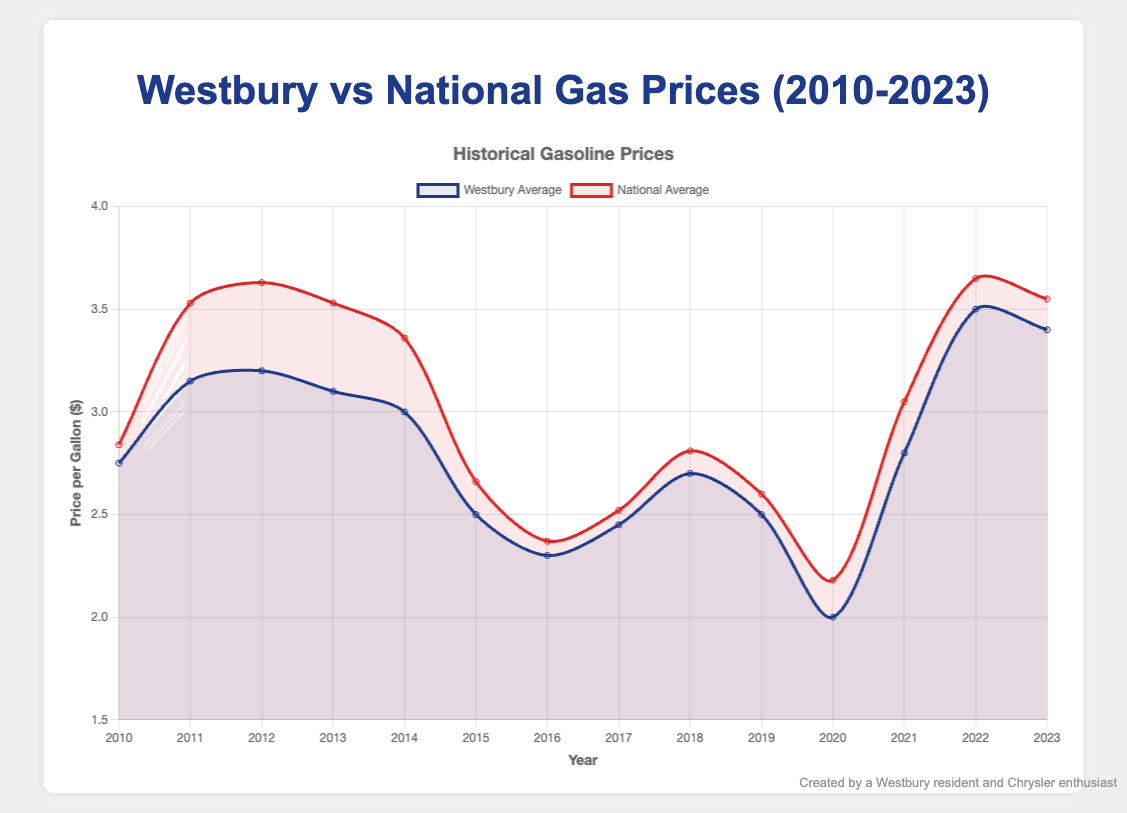What was the highest average gas price in Westbury, and in which year did it occur? To find this, look for the highest point in the blue line representing Westbury. The peak is $3.50 in 2022.
Answer: $3.50 in 2022 In which year was the difference between Westbury and the national average gasoline prices the largest? Calculate the absolute difference for each year. The largest difference is in 2012 with Westbury at $3.20 and the national average at $3.63, resulting in a difference of $0.43.
Answer: 2012 Compare the trends in gasoline prices for Westbury and the national average from 2010 to 2023. Did they generally follow the same pattern? Both lines should be compared for overall upward and downward trends. Both lines show similar oscillations over the years, albeit at slightly different values.
Answer: Yes Was there any year in which Westbury's average gas price was higher than the national average? Look for points where the blue line is above the red line. There is no such year; Westbury's prices were always lower or equal.
Answer: No What was the price difference between the Westbury and national averages in 2023? Subtract Westbury's price from the national average for 2023. $3.55 (national average) - $3.40 (Westbury) = $0.15.
Answer: $0.15 How did gasoline prices in Westbury change from 2020 to 2021? Check the value of the blue line in 2020 and compare it to 2021. Prices increased from $2.00 in 2020 to $2.80 in 2021.
Answer: Increased by $0.80 What visual cues indicate the price fluctuations in the chart? Observe the lines' heights, slope, and color. Steep slopes indicate rapid changes, the blue color represents Westbury, and the red color represents the national average.
Answer: Line slopes and colors Which year experienced the largest decrease in gasoline prices in Westbury? Identify the steepest downward slope on the blue line. The largest decrease happened from 2014 ($3.00) to 2015 ($2.50), a drop of $0.50.
Answer: 2014 to 2015 Calculate the average gasoline price in Westbury over the 14-year period. Sum all the yearly prices for Westbury and divide by the number of years (14). (2.75 + 3.15 + 3.20 + 3.10 + 3.00 + 2.50 + 2.30 + 2.45 + 2.70 + 2.50 + 2.00 + 2.80 + 3.50 + 3.40)/14 = 2.807
Answer: $2.81 